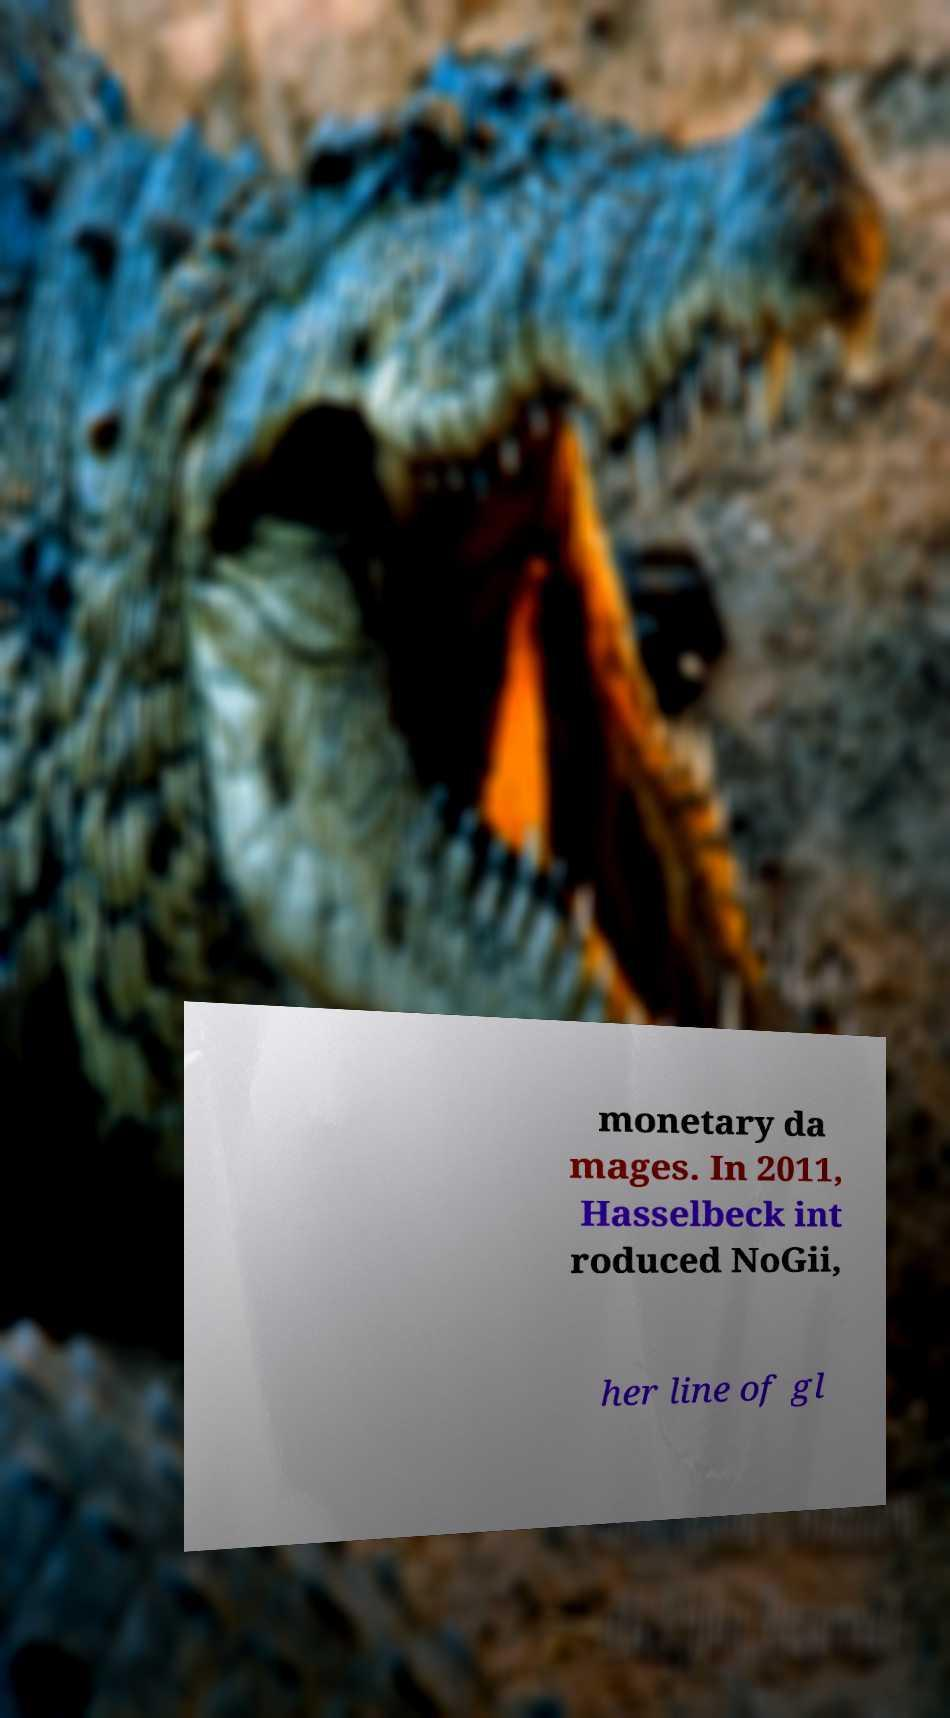I need the written content from this picture converted into text. Can you do that? monetary da mages. In 2011, Hasselbeck int roduced NoGii, her line of gl 